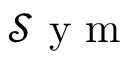Convert formula to latex. <formula><loc_0><loc_0><loc_500><loc_500>\mathcal { S } y m</formula> 